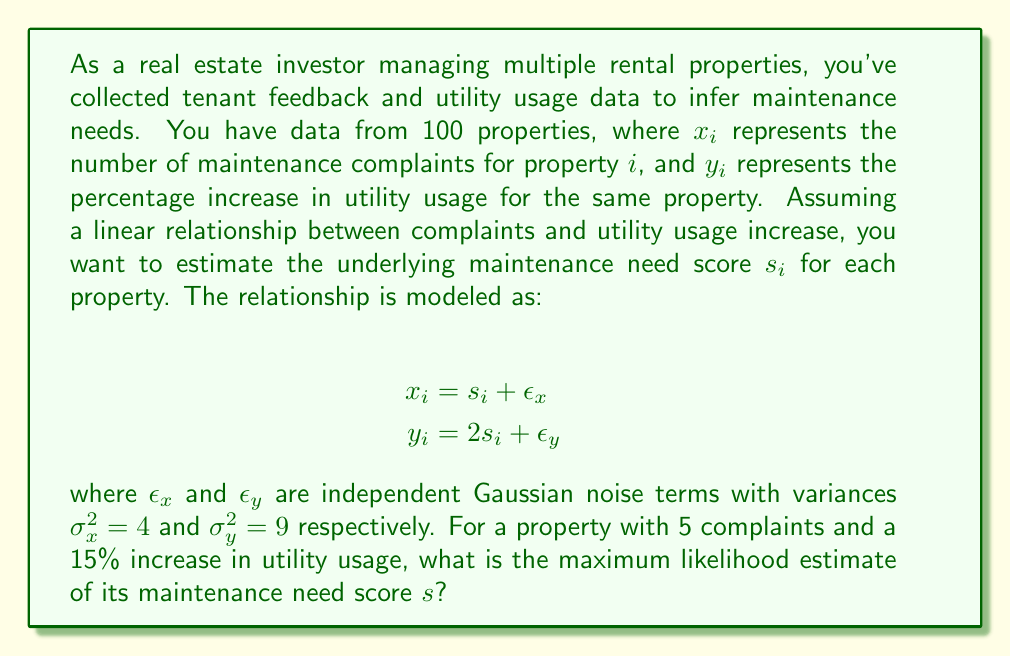Could you help me with this problem? To solve this inverse problem and find the maximum likelihood estimate of the maintenance need score $s$, we'll follow these steps:

1) The problem setup gives us two observations:
   $x = 5$ (complaints)
   $y = 15$ (percent increase in utility usage)

2) We have a linear system:
   $x = s + \epsilon_x$
   $y = 2s + \epsilon_y$

3) The maximum likelihood estimate minimizes the sum of squared residuals, weighted by the inverse of their variances. We want to minimize:

   $$J(s) = \frac{(x-s)^2}{\sigma_x^2} + \frac{(y-2s)^2}{\sigma_y^2}$$

4) Substituting the known values:

   $$J(s) = \frac{(5-s)^2}{4} + \frac{(15-2s)^2}{9}$$

5) To find the minimum, we differentiate $J(s)$ with respect to $s$ and set it to zero:

   $$\frac{dJ}{ds} = -\frac{2(5-s)}{4} - \frac{4(15-2s)}{9} = 0$$

6) Simplifying:

   $$-\frac{1}{2}(5-s) - \frac{4}{9}(15-2s) = 0$$
   $$-\frac{9}{18}(5-s) - \frac{8}{18}(15-2s) = 0$$
   $$-45+9s - 120+16s = 0$$
   $$25s = 165$$

7) Solving for $s$:

   $$s = \frac{165}{25} = 6.6$$

Therefore, the maximum likelihood estimate of the maintenance need score $s$ is 6.6.
Answer: 6.6 